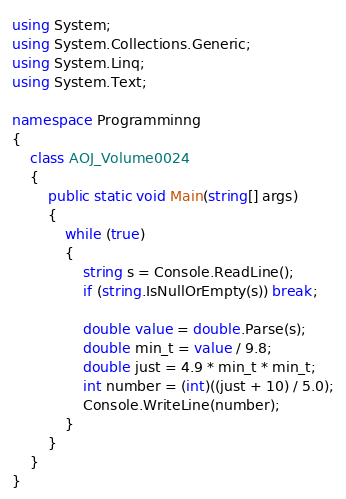<code> <loc_0><loc_0><loc_500><loc_500><_C#_>using System;
using System.Collections.Generic;
using System.Linq;
using System.Text;

namespace Programminng
{
    class AOJ_Volume0024
    {
        public static void Main(string[] args)
        {
            while (true)
            {
                string s = Console.ReadLine();
                if (string.IsNullOrEmpty(s)) break;

                double value = double.Parse(s);
                double min_t = value / 9.8;
                double just = 4.9 * min_t * min_t;
                int number = (int)((just + 10) / 5.0);
                Console.WriteLine(number);
            }
        }
    }
}</code> 